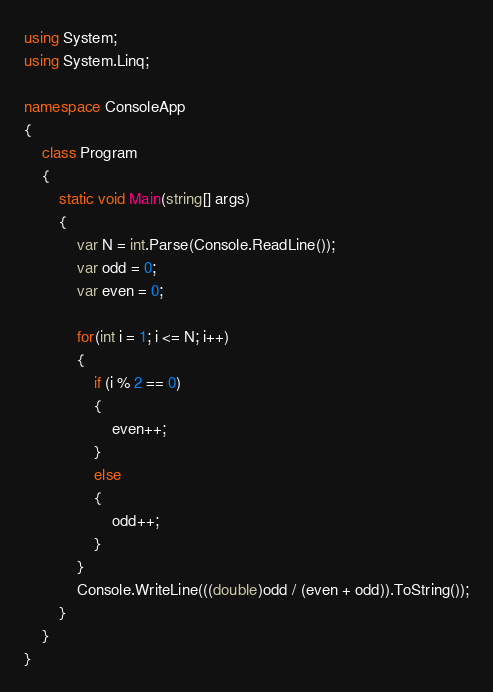<code> <loc_0><loc_0><loc_500><loc_500><_C#_>using System;
using System.Linq;

namespace ConsoleApp
{
    class Program
    {
        static void Main(string[] args)
        {
            var N = int.Parse(Console.ReadLine());
            var odd = 0;
            var even = 0;

            for(int i = 1; i <= N; i++)
            {
                if (i % 2 == 0)
                {
                    even++;
                }
                else
                {
                    odd++;
                }
            }
            Console.WriteLine(((double)odd / (even + odd)).ToString());
        }
    }
}
</code> 